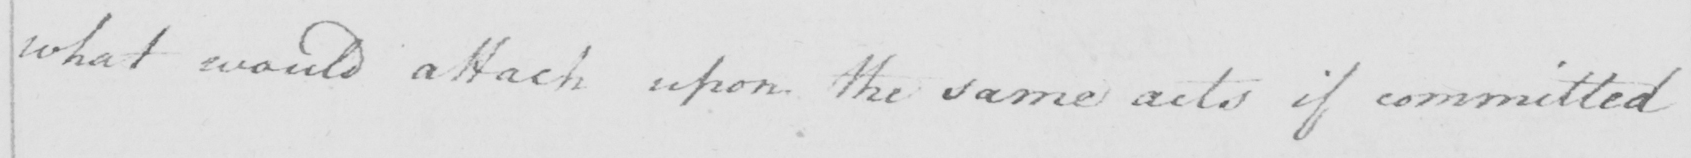What does this handwritten line say? what would attach upon the same acts if committed 